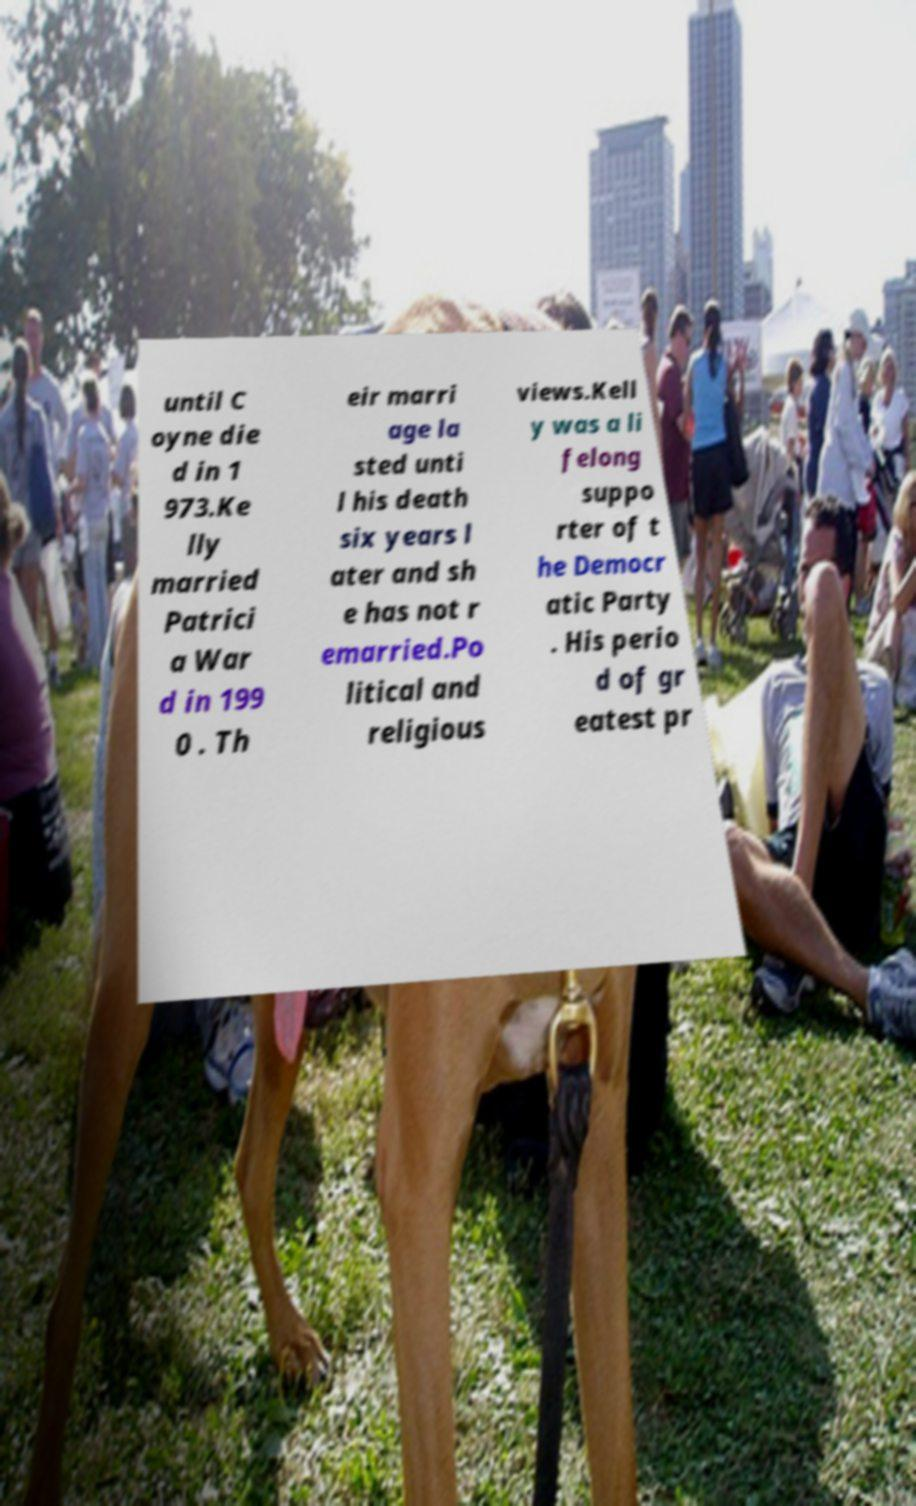Can you read and provide the text displayed in the image?This photo seems to have some interesting text. Can you extract and type it out for me? until C oyne die d in 1 973.Ke lly married Patrici a War d in 199 0 . Th eir marri age la sted unti l his death six years l ater and sh e has not r emarried.Po litical and religious views.Kell y was a li felong suppo rter of t he Democr atic Party . His perio d of gr eatest pr 